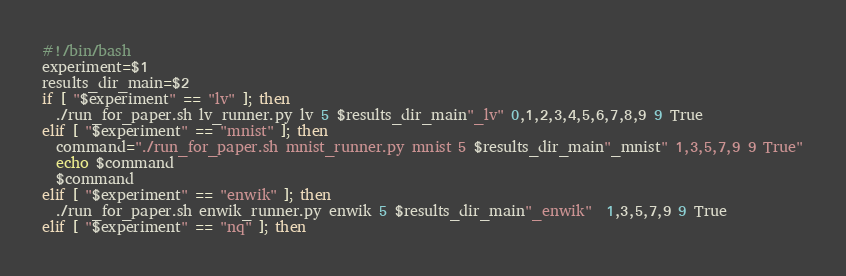<code> <loc_0><loc_0><loc_500><loc_500><_Bash_>#!/bin/bash
experiment=$1
results_dir_main=$2
if [ "$experiment" == "lv" ]; then
  ./run_for_paper.sh lv_runner.py lv 5 $results_dir_main"_lv" 0,1,2,3,4,5,6,7,8,9 9 True
elif [ "$experiment" == "mnist" ]; then
  command="./run_for_paper.sh mnist_runner.py mnist 5 $results_dir_main"_mnist" 1,3,5,7,9 9 True"
  echo $command
  $command
elif [ "$experiment" == "enwik" ]; then
  ./run_for_paper.sh enwik_runner.py enwik 5 $results_dir_main"_enwik"  1,3,5,7,9 9 True
elif [ "$experiment" == "nq" ]; then</code> 